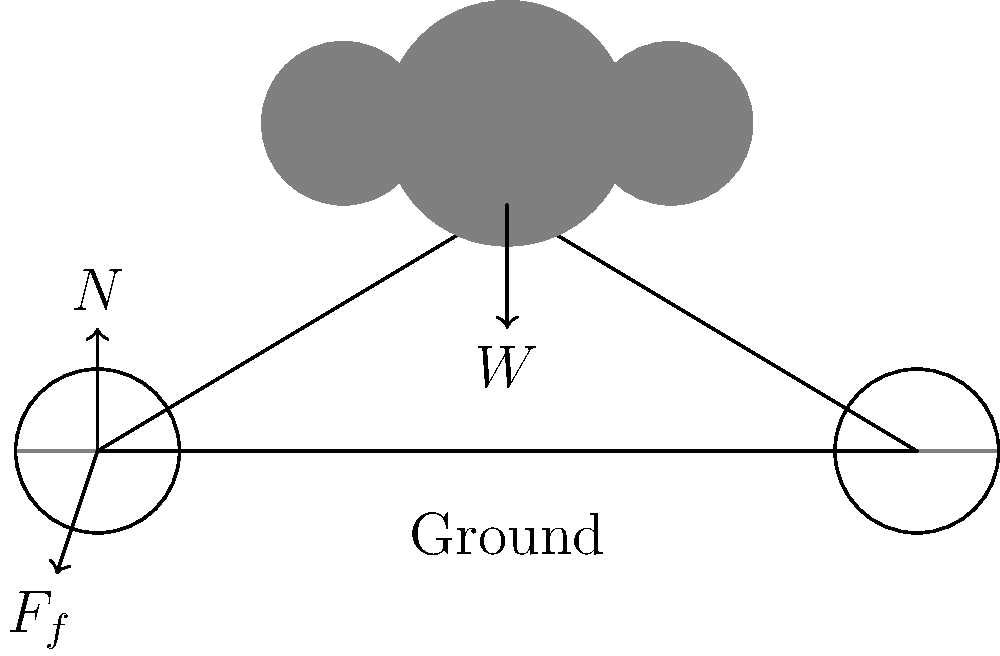A family of three is riding a bicycle together on a flat surface. The diagram shows the forces acting on the bicycle. If the total weight of the family and bicycle is 200 N, what is the magnitude of the normal force ($N$) exerted by the ground on the bicycle? To solve this problem, we need to consider the forces acting on the bicycle and family system:

1. The weight ($W$) of the family and bicycle acts downward due to gravity.
2. The normal force ($N$) acts upward, perpendicular to the ground.
3. The friction force ($F_f$) acts horizontally, opposing the motion of the bicycle.

Since the bicycle is moving on a flat surface without accelerating vertically, we can conclude that the forces in the vertical direction are balanced. This means:

1. The sum of vertical forces is zero: $\sum F_y = 0$
2. Normal force ($N$) is equal and opposite to the weight ($W$): $N - W = 0$
3. Therefore, $N = W = 200$ N

The normal force must be equal in magnitude to the total weight of the family and bicycle to keep them from sinking into the ground or floating away.
Answer: 200 N 